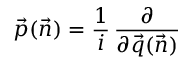<formula> <loc_0><loc_0><loc_500><loc_500>\vec { p } ( \vec { n } ) = { \frac { 1 } { i } } \, { \frac { \partial } { \partial \vec { q } ( \vec { n } ) } }</formula> 